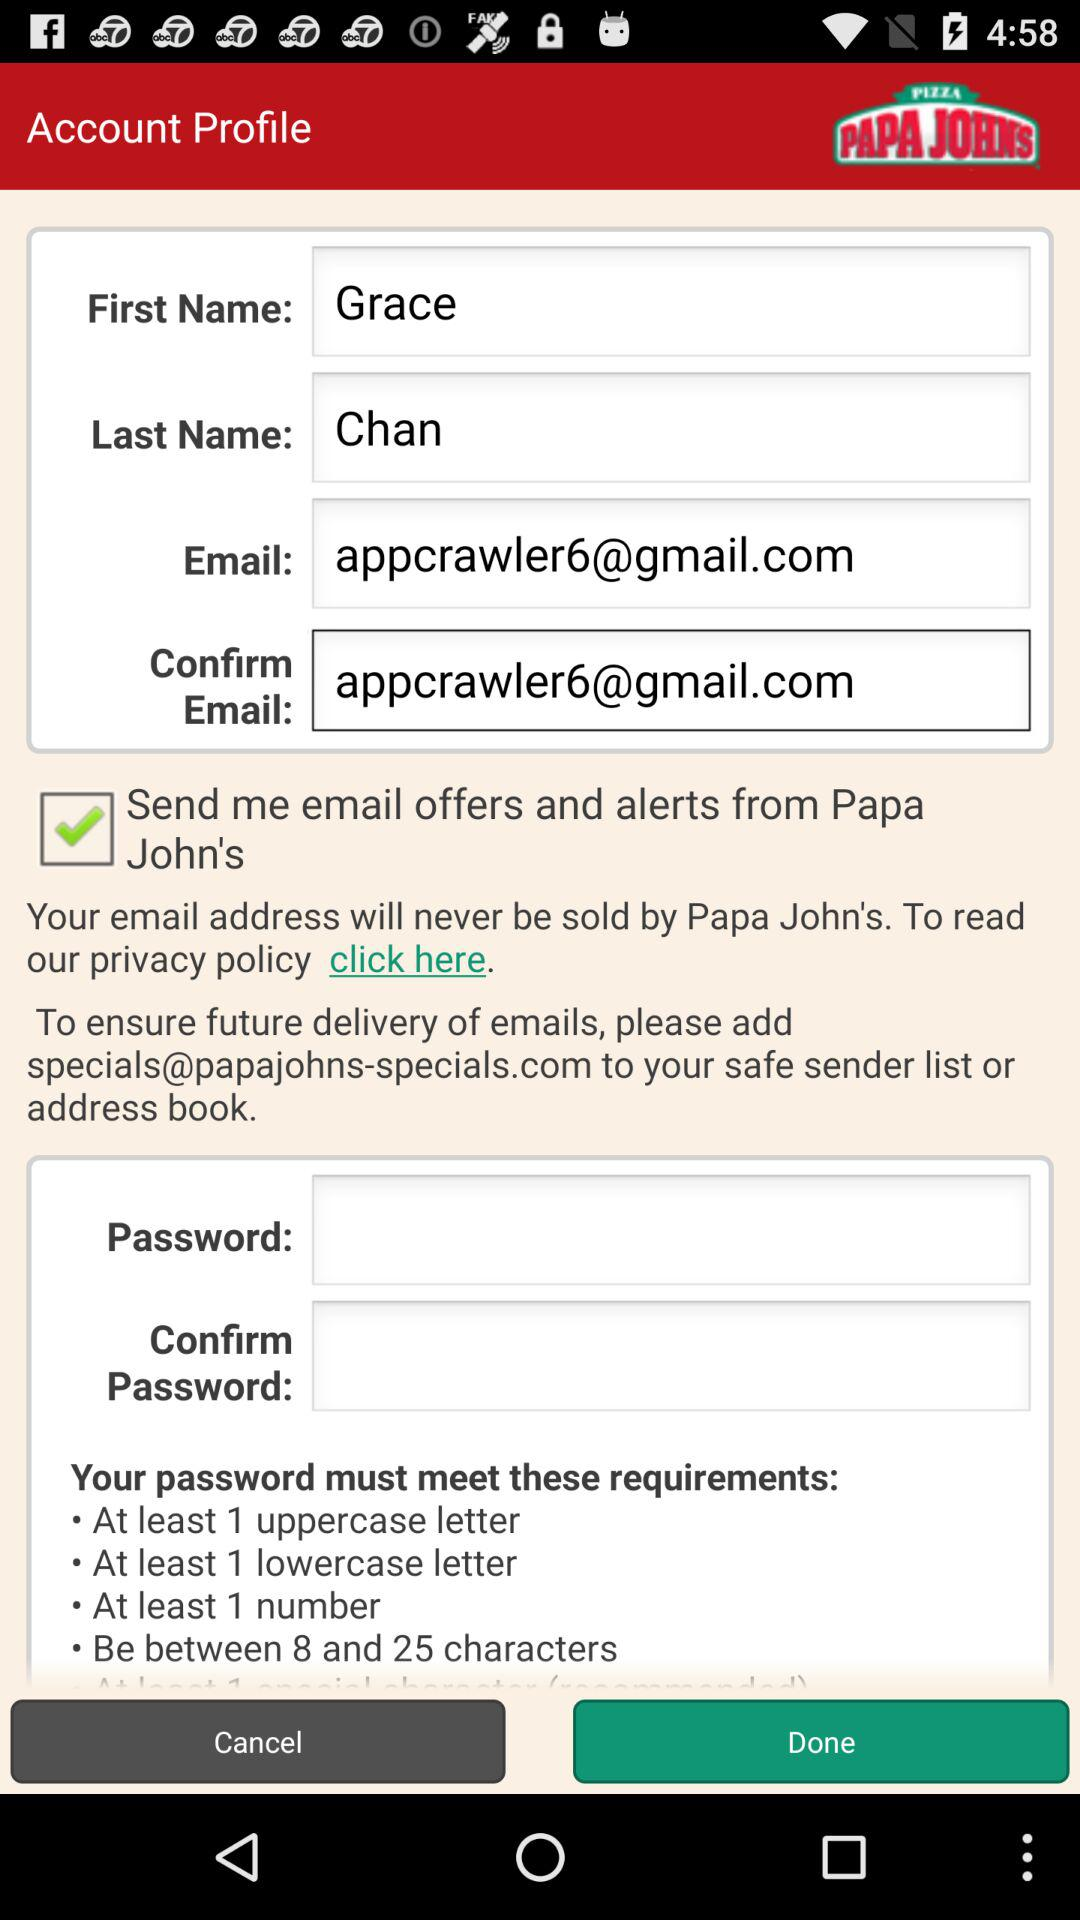What is the current status of "Send me email offers and alerts from Papa John's"? The current status is "on". 